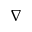<formula> <loc_0><loc_0><loc_500><loc_500>\nabla</formula> 